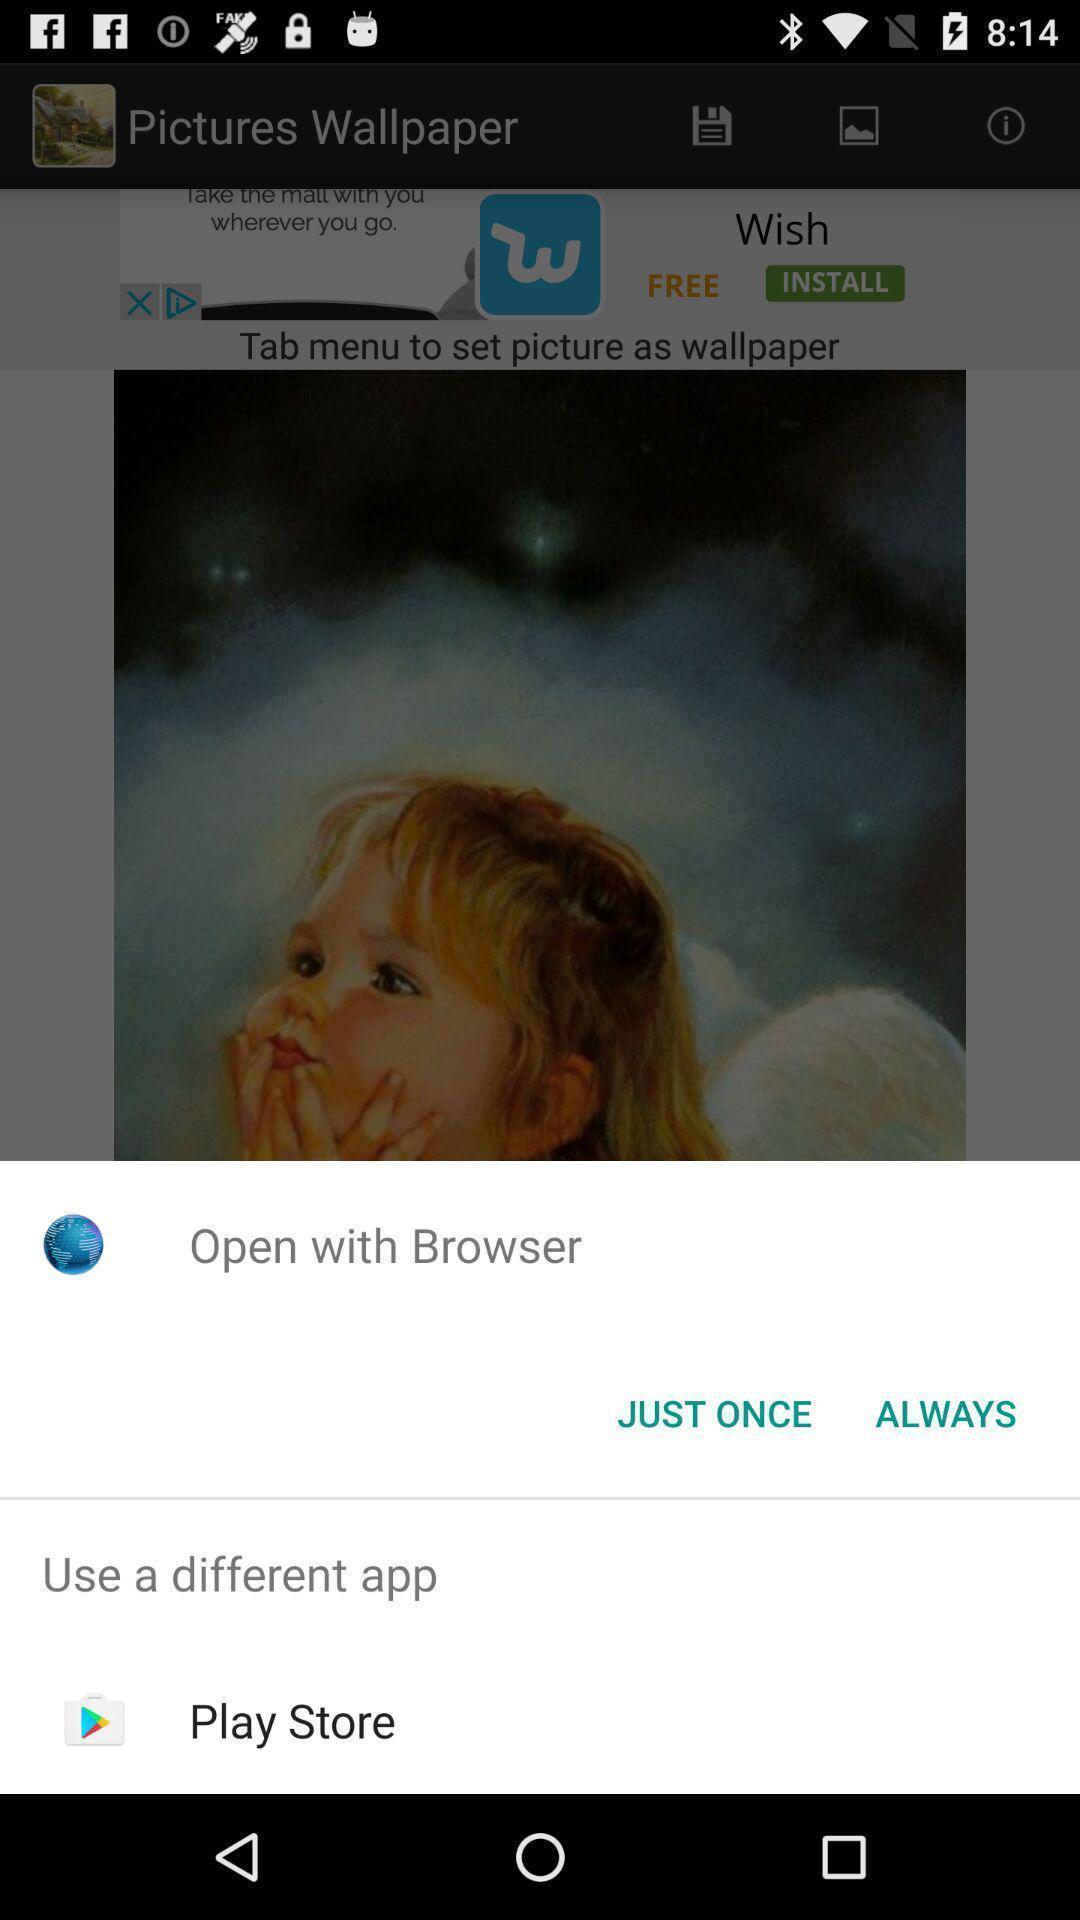What details can you identify in this image? Pop-up with options to open from. 